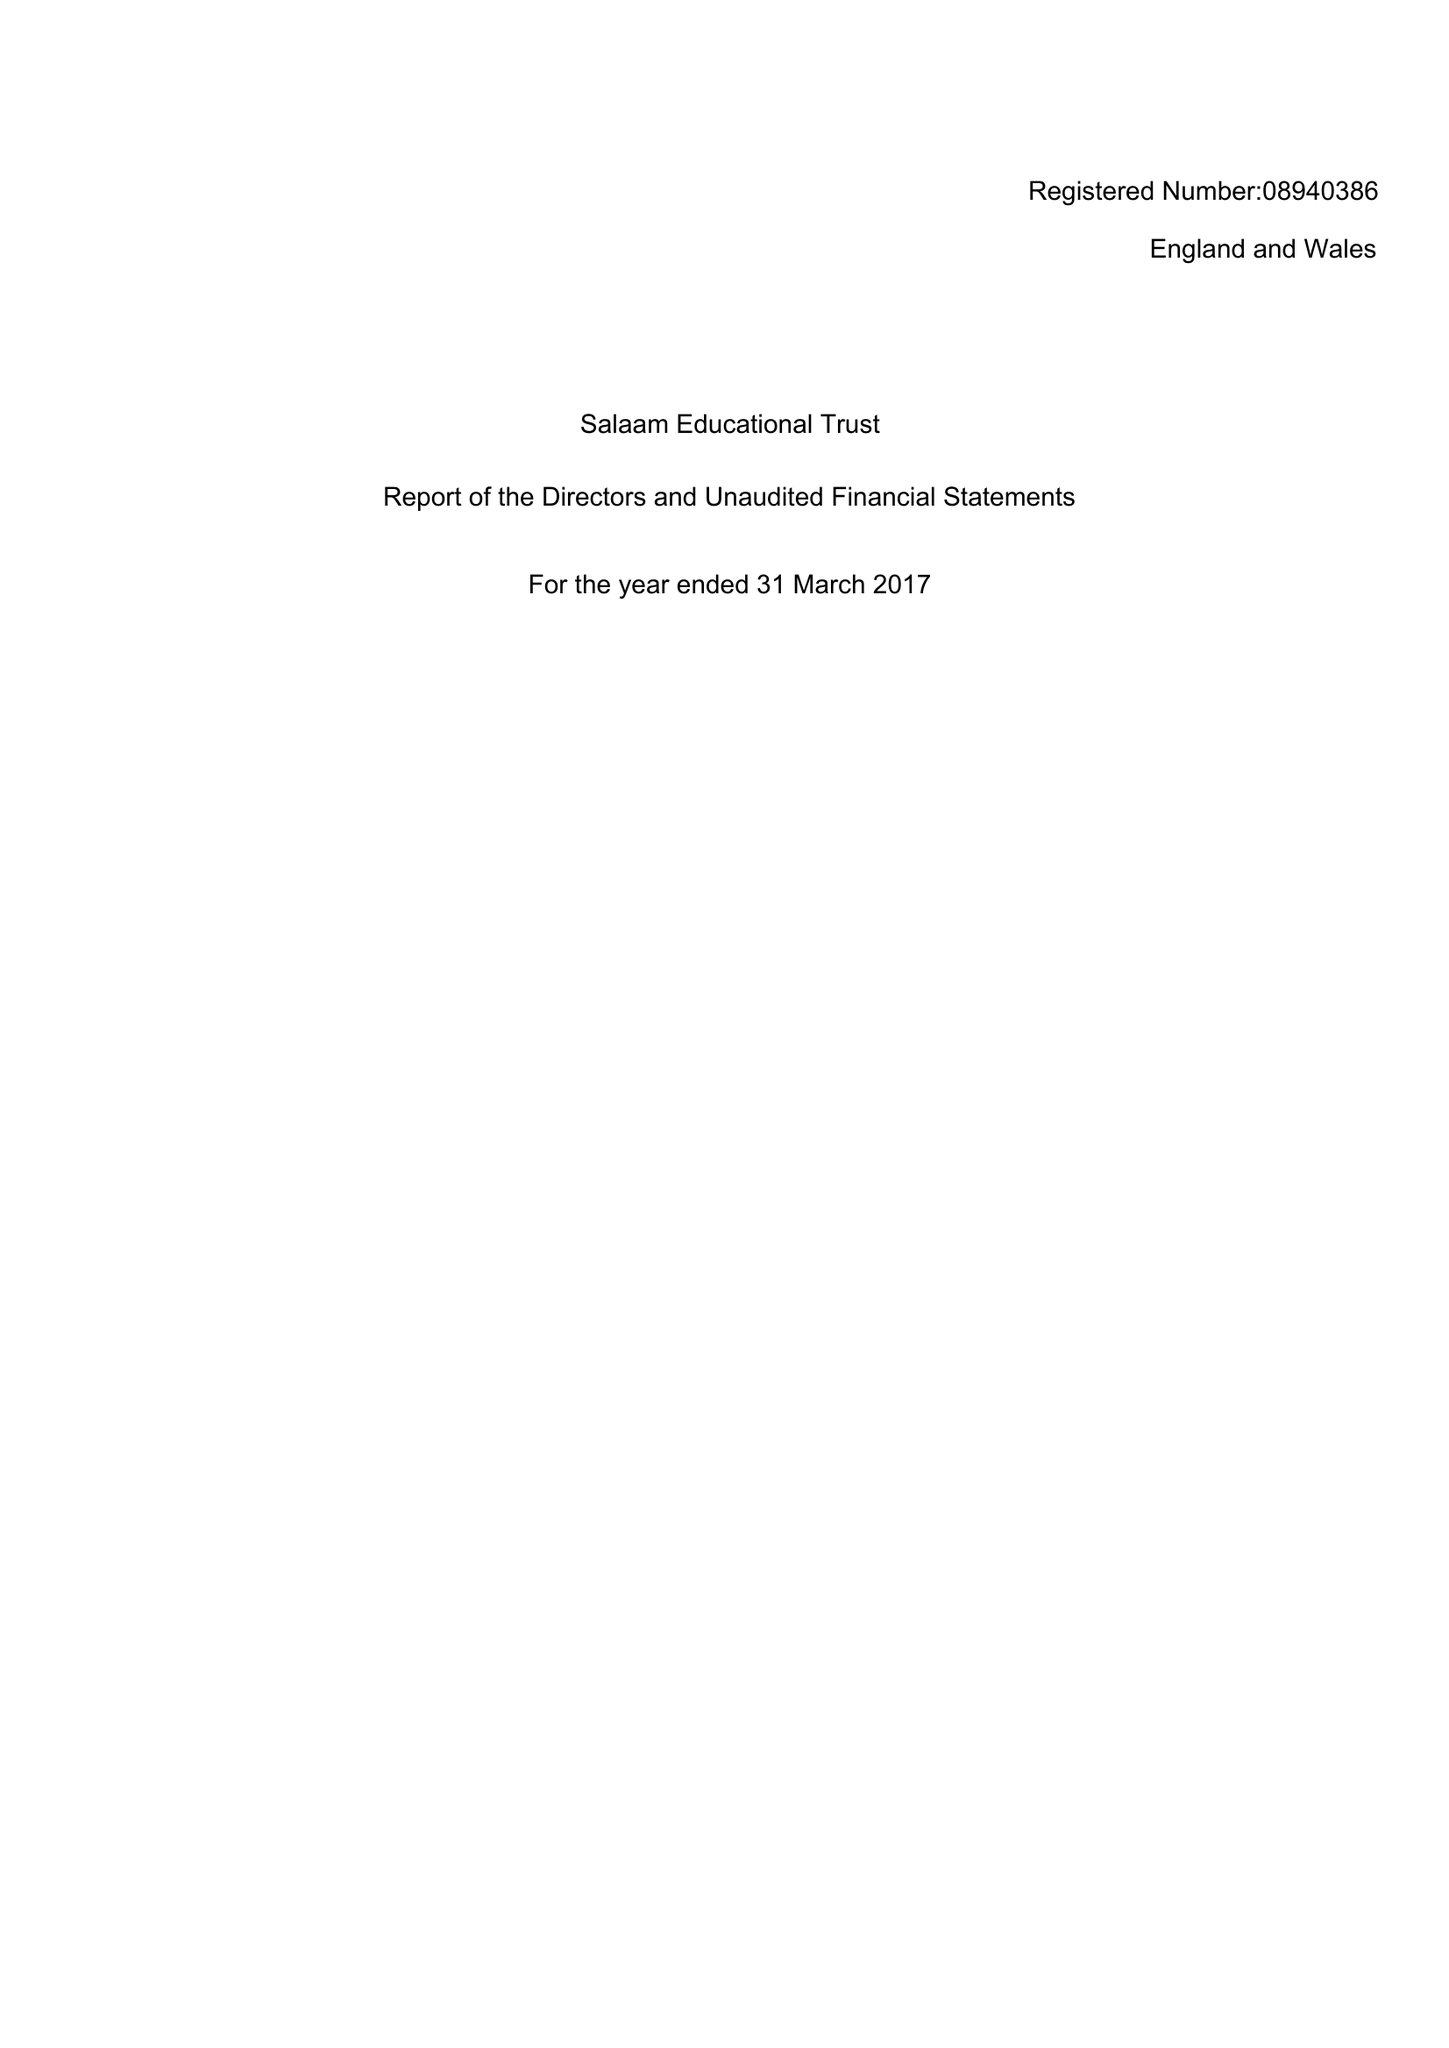What is the value for the charity_name?
Answer the question using a single word or phrase. Salaam Educational Trust Ltd. 